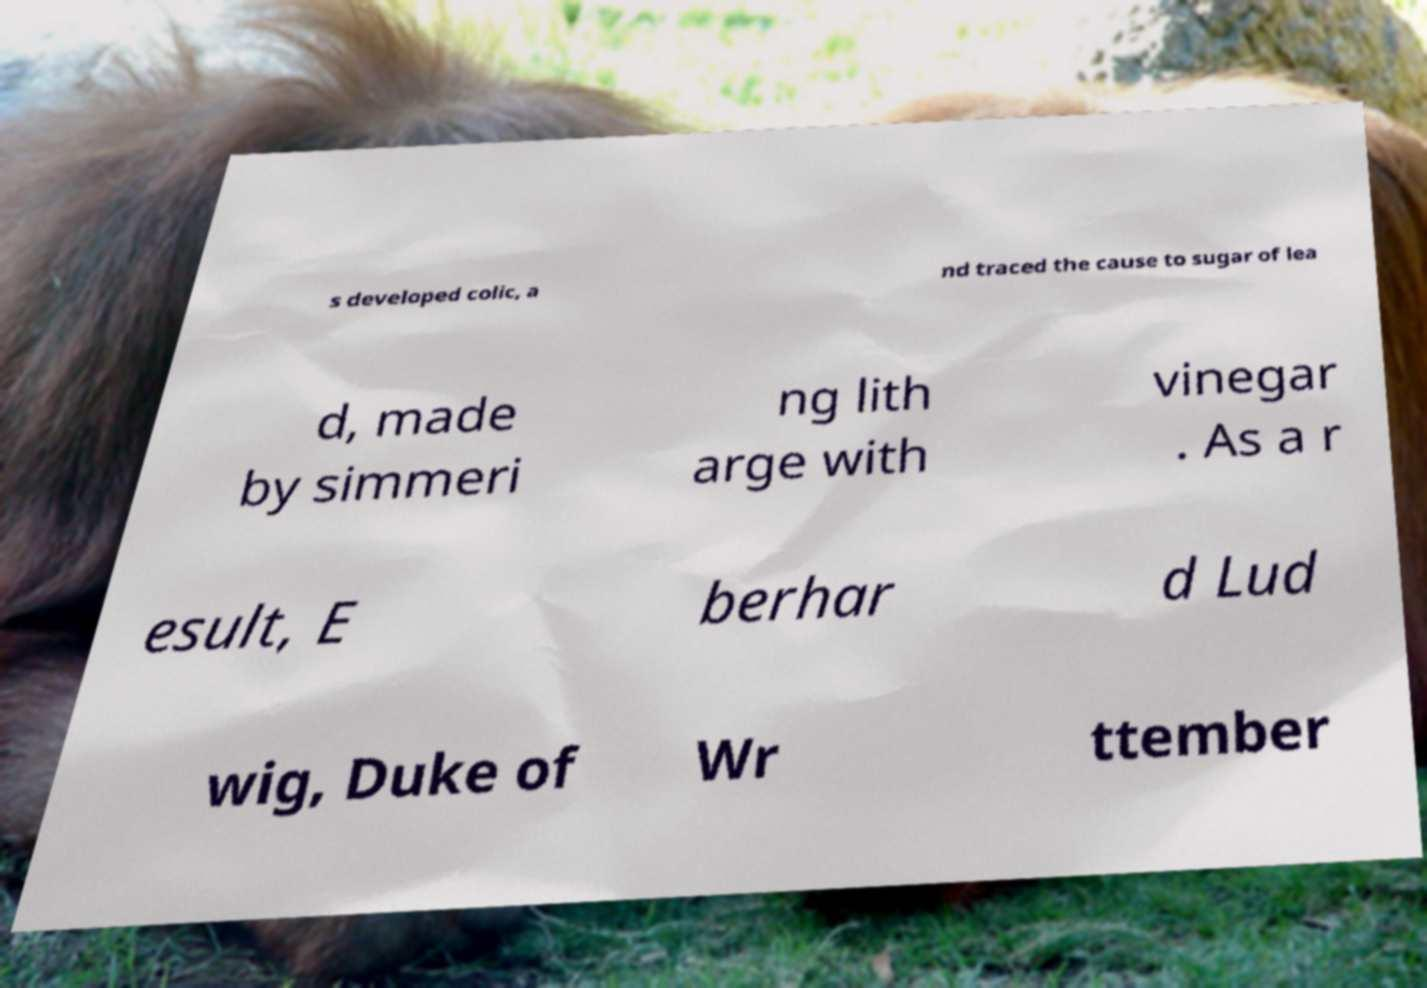Can you accurately transcribe the text from the provided image for me? s developed colic, a nd traced the cause to sugar of lea d, made by simmeri ng lith arge with vinegar . As a r esult, E berhar d Lud wig, Duke of Wr ttember 